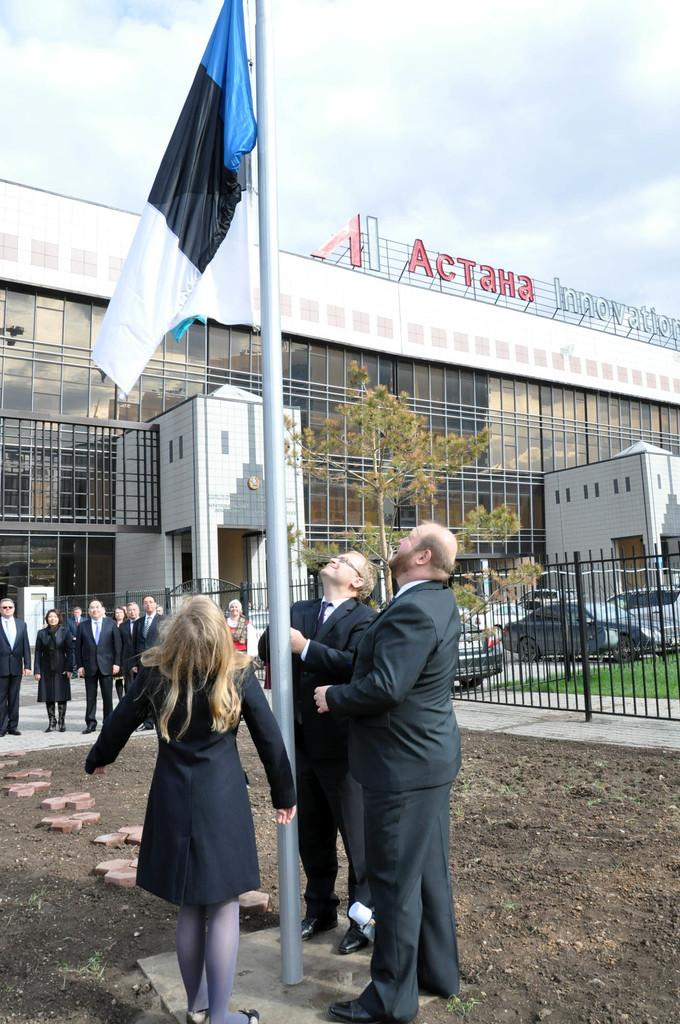What is the main object in the image? There is a pole in the image. What is attached to the pole? There is a flag attached to the pole. Can you describe the people in the image? There are people in the image, but their specific actions or appearances are not mentioned in the facts. What type of barrier is present in the image? There is a fence in the image. What type of vehicles can be seen in the image? There are cars in the image. What type of vegetation is present in the image? There is grass in the image. What is the board used for in the image? The facts do not specify the purpose of the board in the image. What is visible beneath the people and objects in the image? There is ground visible in the image. What type of structure is present in the image? There is a building in the image. What can be seen in the background of the image? The sky is visible in the background of the image, and there are clouds in the sky. Where is the mailbox located in the image? There is no mention of a mailbox in the image. What type of polish is being applied to the cars in the image? There is no mention of polish or any car maintenance activities in the image. How does the digestion of the people in the image affect their behavior? There is no information about the people's digestion or behavior in the image. 